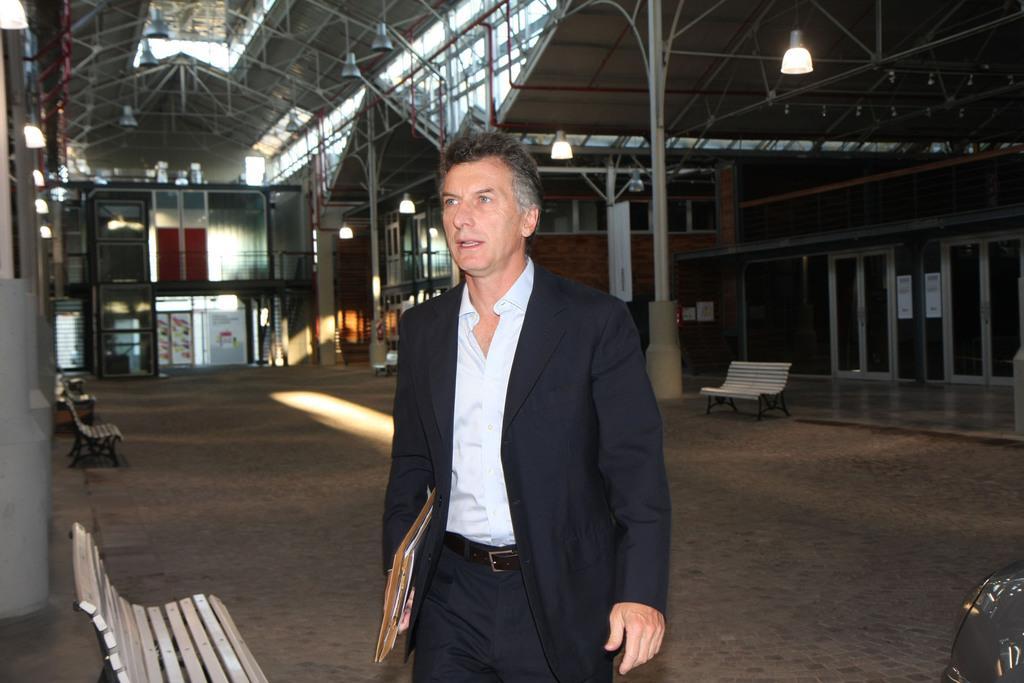Please provide a concise description of this image. In this image I see a man who is wearing a suit and holding some files in his hands and I see few benches on the path. In the background I see the lights and the sheds. 